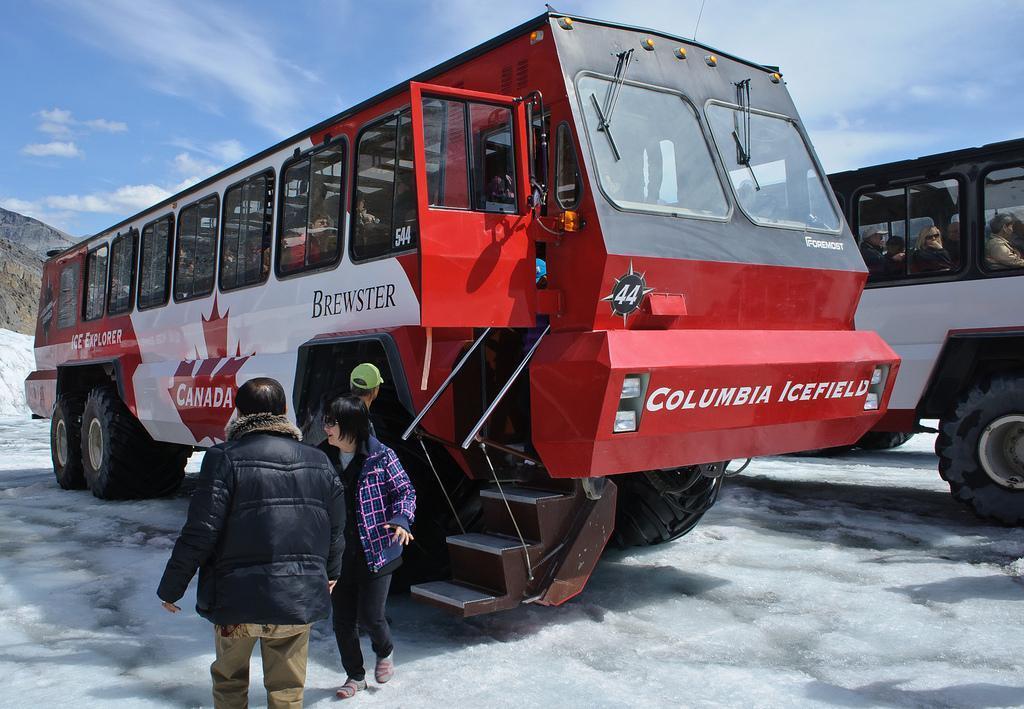How many windshields does the bus have?
Give a very brief answer. 2. How many vehicles are there?
Give a very brief answer. 2. How many vehicles are pictured?
Give a very brief answer. 2. How many people are pictured?
Give a very brief answer. 3. How many windows are on the side of the bus, not including the door window?
Give a very brief answer. 7. How many windshields?
Give a very brief answer. 2. 